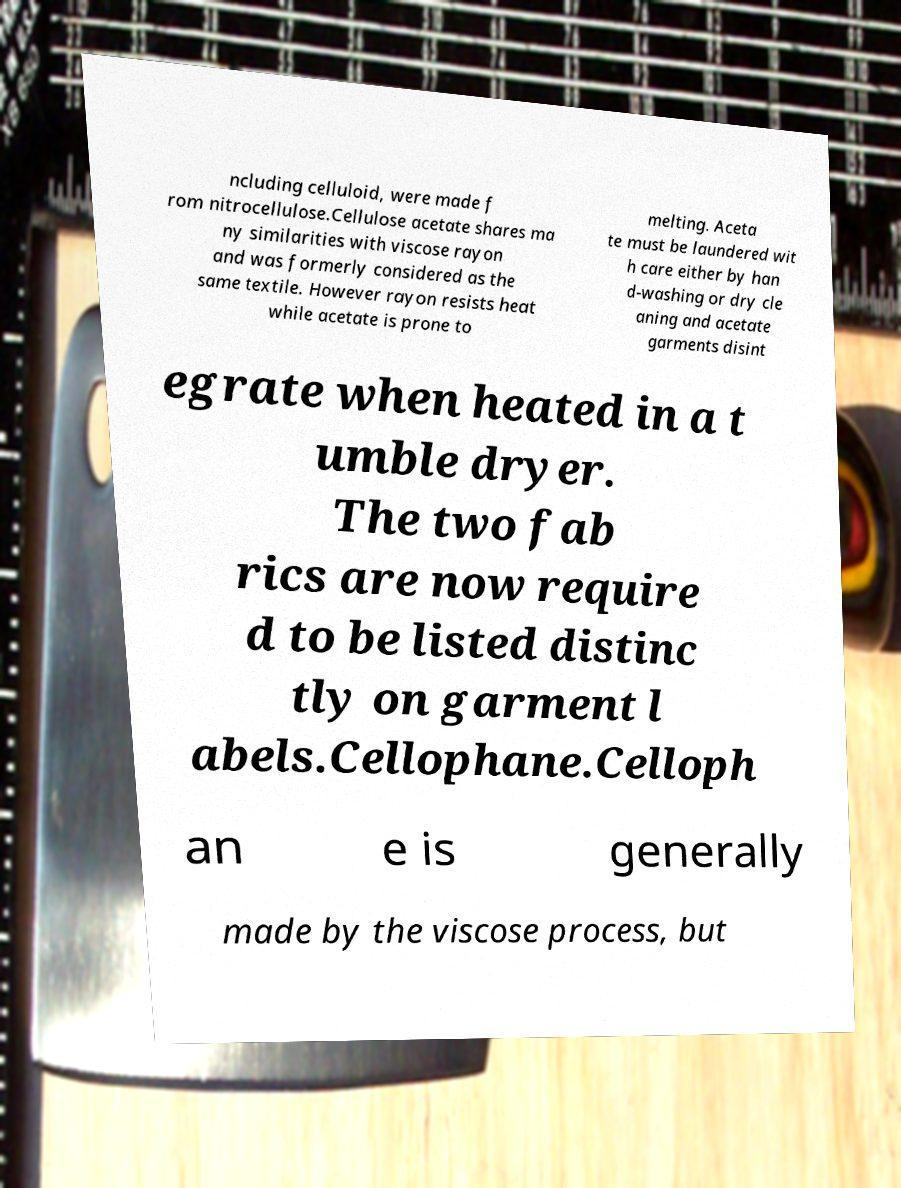There's text embedded in this image that I need extracted. Can you transcribe it verbatim? ncluding celluloid, were made f rom nitrocellulose.Cellulose acetate shares ma ny similarities with viscose rayon and was formerly considered as the same textile. However rayon resists heat while acetate is prone to melting. Aceta te must be laundered wit h care either by han d-washing or dry cle aning and acetate garments disint egrate when heated in a t umble dryer. The two fab rics are now require d to be listed distinc tly on garment l abels.Cellophane.Celloph an e is generally made by the viscose process, but 